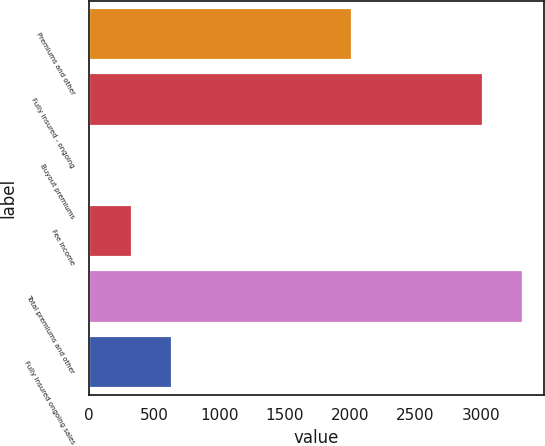Convert chart to OTSL. <chart><loc_0><loc_0><loc_500><loc_500><bar_chart><fcel>Premiums and other<fcel>Fully insured - ongoing<fcel>Buyout premiums<fcel>Fee income<fcel>Total premiums and other<fcel>Fully insured ongoing sales<nl><fcel>2014<fcel>3014<fcel>20<fcel>327.5<fcel>3321.5<fcel>635<nl></chart> 